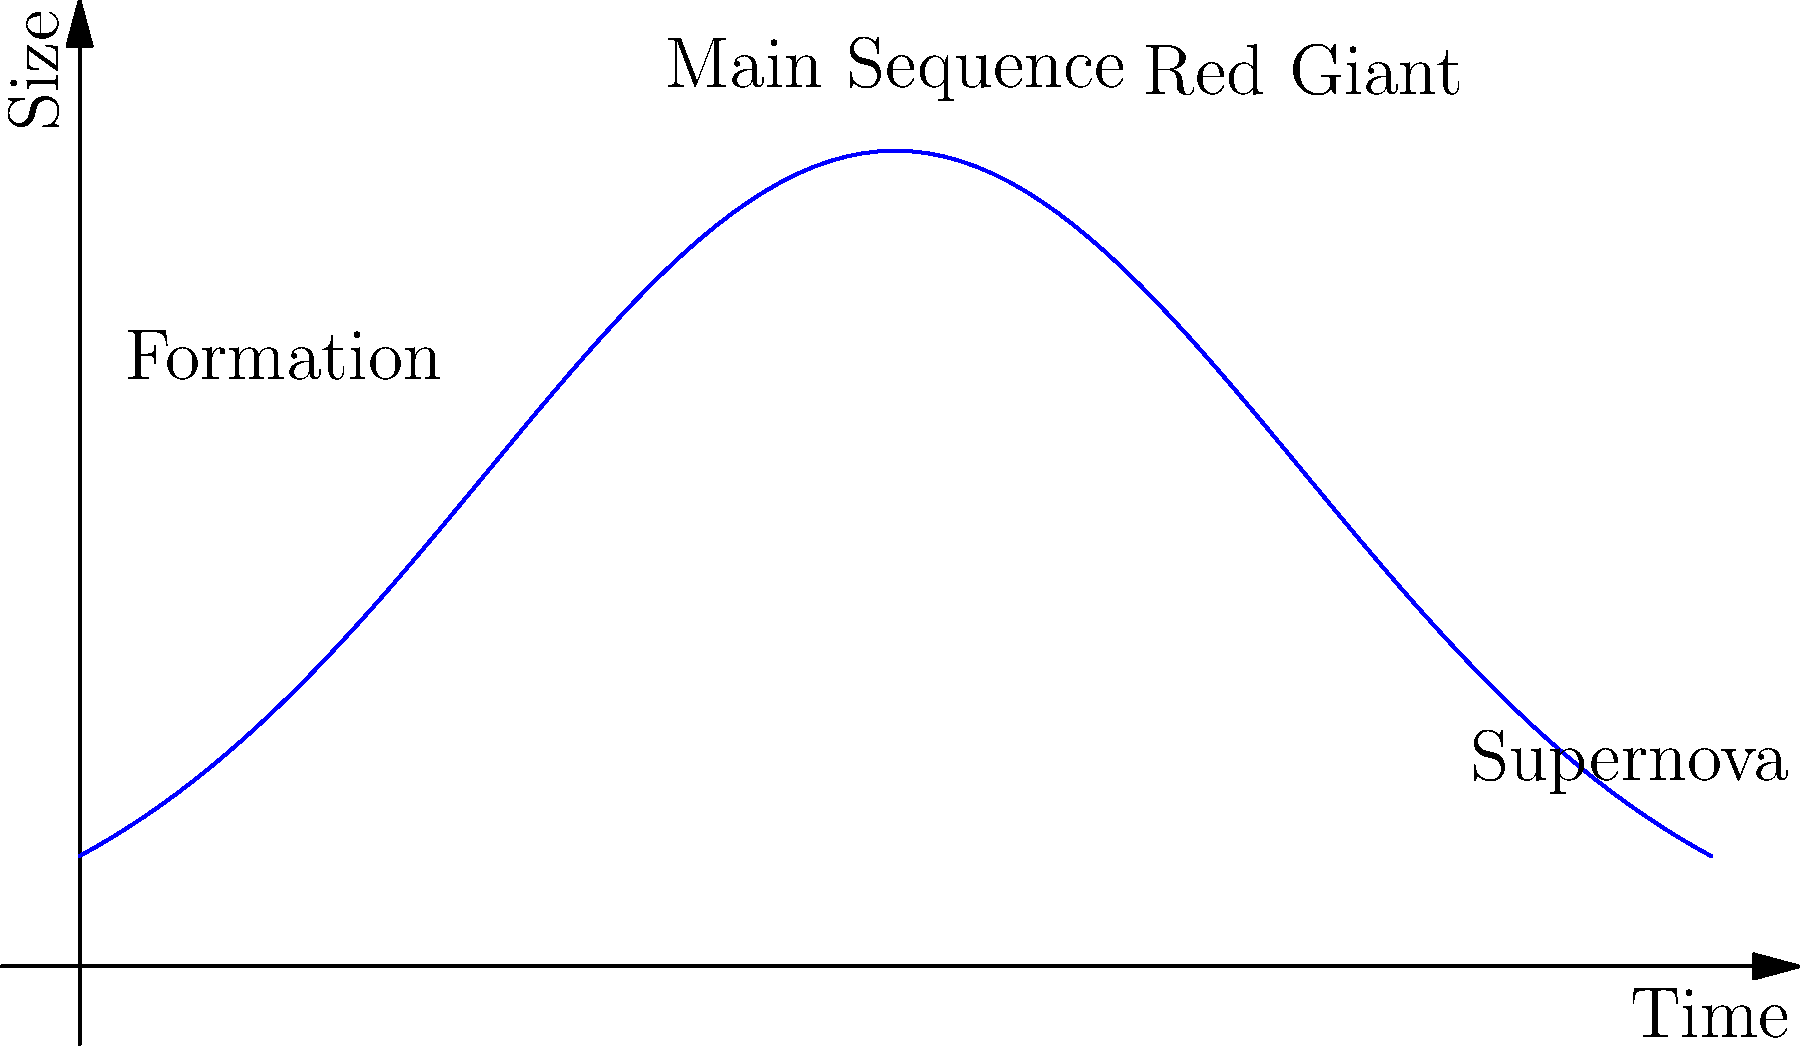In the context of star evolution, which stage typically lasts the longest and is characterized by a stable balance between gravitational collapse and nuclear fusion? The life cycle of a star can be broken down into several key stages:

1. Formation: A star begins as a cloud of gas and dust that collapses under its own gravity.

2. Main Sequence: This is the longest and most stable phase of a star's life. During this stage:
   - The star maintains a balance between gravitational collapse and the outward pressure from nuclear fusion.
   - Hydrogen is fused into helium in the star's core.
   - The star's size and temperature remain relatively constant.
   - For a star like our Sun, this phase lasts about 10 billion years.

3. Red Giant: As the hydrogen in the core is depleted, the star expands and cools, becoming a red giant.

4. Final Stages: Depending on the star's mass, it may end as a white dwarf, neutron star, or black hole. Massive stars may experience a supernova explosion.

The Main Sequence stage is typically the longest-lasting phase in a star's life, characterized by the stable fusion of hydrogen into helium, maintaining a balance between gravitational forces and fusion pressure.
Answer: Main Sequence 